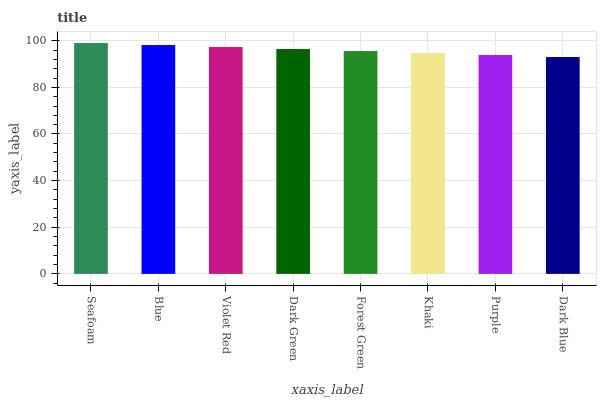Is Dark Blue the minimum?
Answer yes or no. Yes. Is Seafoam the maximum?
Answer yes or no. Yes. Is Blue the minimum?
Answer yes or no. No. Is Blue the maximum?
Answer yes or no. No. Is Seafoam greater than Blue?
Answer yes or no. Yes. Is Blue less than Seafoam?
Answer yes or no. Yes. Is Blue greater than Seafoam?
Answer yes or no. No. Is Seafoam less than Blue?
Answer yes or no. No. Is Dark Green the high median?
Answer yes or no. Yes. Is Forest Green the low median?
Answer yes or no. Yes. Is Khaki the high median?
Answer yes or no. No. Is Seafoam the low median?
Answer yes or no. No. 